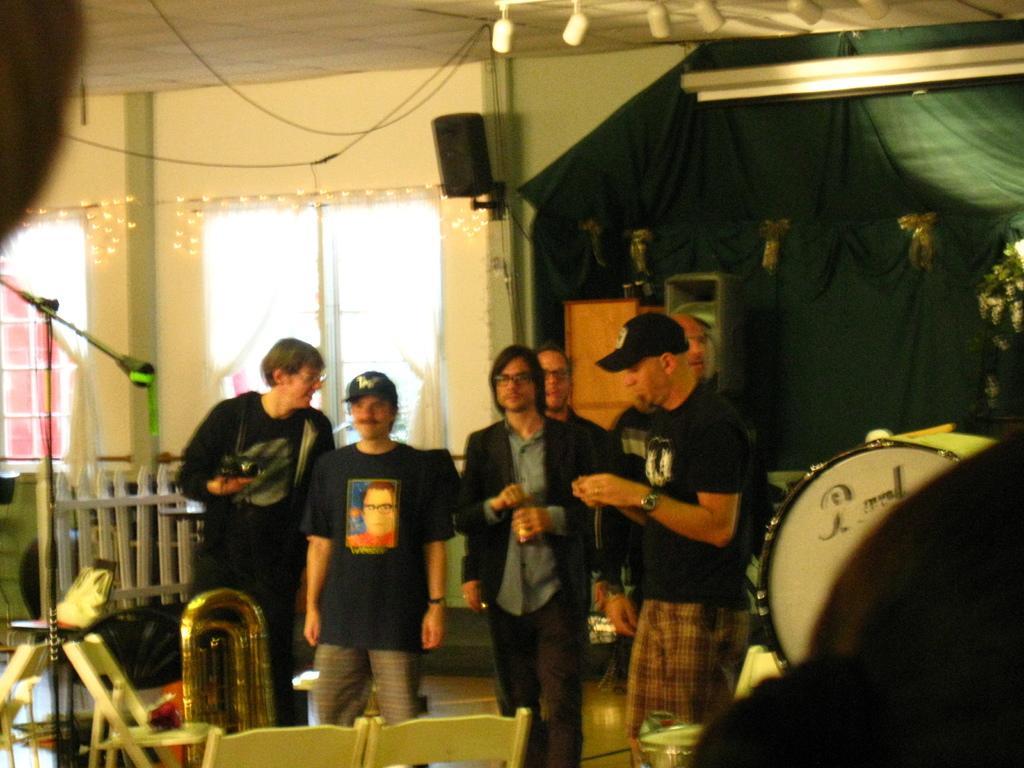Can you describe this image briefly? In this image we can see men are standing. At the bottom of the image, we can see chairs, bag and musical instruments. In the background, we can see windows, wall, curtain and a wooden object. On the left side of the image, we can see stand and a fence. At the top of the image, we can see the roof, lights and a sound box. 